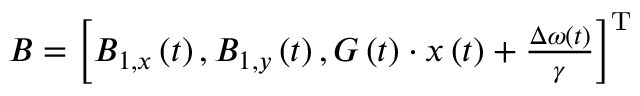Convert formula to latex. <formula><loc_0><loc_0><loc_500><loc_500>\begin{array} { r } { B = \left [ B _ { 1 , x } \left ( t \right ) , B _ { 1 , y } \left ( t \right ) , G \left ( t \right ) \cdot x \left ( t \right ) + \frac { \Delta \omega ( t ) } { \gamma } \right ] ^ { T } } \end{array}</formula> 